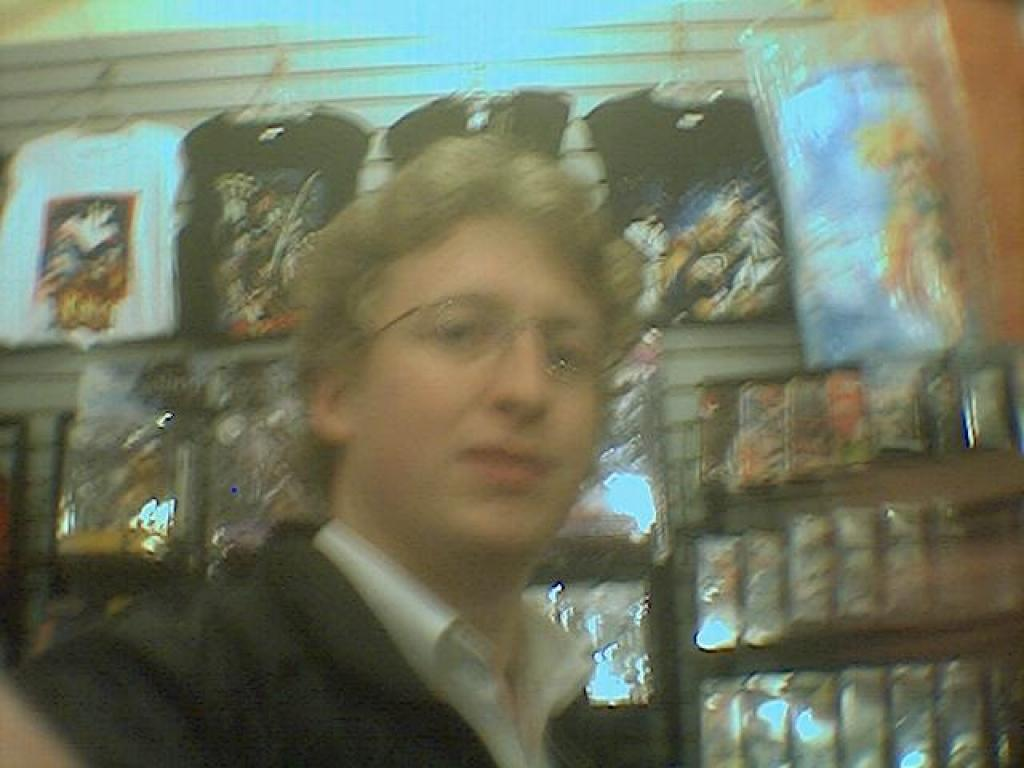Who is present in the image? There is a man in the image. What is the man wearing? The man is wearing a white and black dress. What can be seen in the background of the image? Clothes are hanged on the wall in the background of the image. How would you describe the background of the image? The background of the image is blurred. What type of humor does the man's dad use in the image? There is no mention of the man's dad or any humor in the image. What reward does the man receive for wearing the white and black dress in the image? There is no indication of a reward for wearing the dress in the image. 